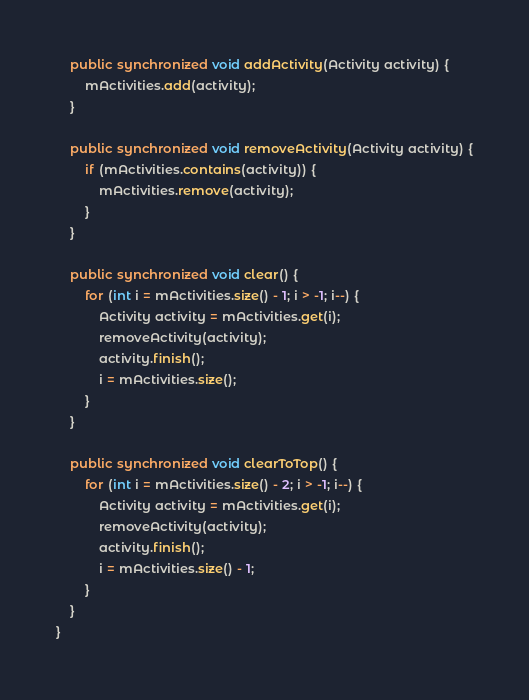<code> <loc_0><loc_0><loc_500><loc_500><_Java_>
    public synchronized void addActivity(Activity activity) {
        mActivities.add(activity);
    }

    public synchronized void removeActivity(Activity activity) {
        if (mActivities.contains(activity)) {
            mActivities.remove(activity);
        }
    }

    public synchronized void clear() {
        for (int i = mActivities.size() - 1; i > -1; i--) {
            Activity activity = mActivities.get(i);
            removeActivity(activity);
            activity.finish();
            i = mActivities.size();
        }
    }

    public synchronized void clearToTop() {
        for (int i = mActivities.size() - 2; i > -1; i--) {
            Activity activity = mActivities.get(i);
            removeActivity(activity);
            activity.finish();
            i = mActivities.size() - 1;
        }
    }
}
</code> 